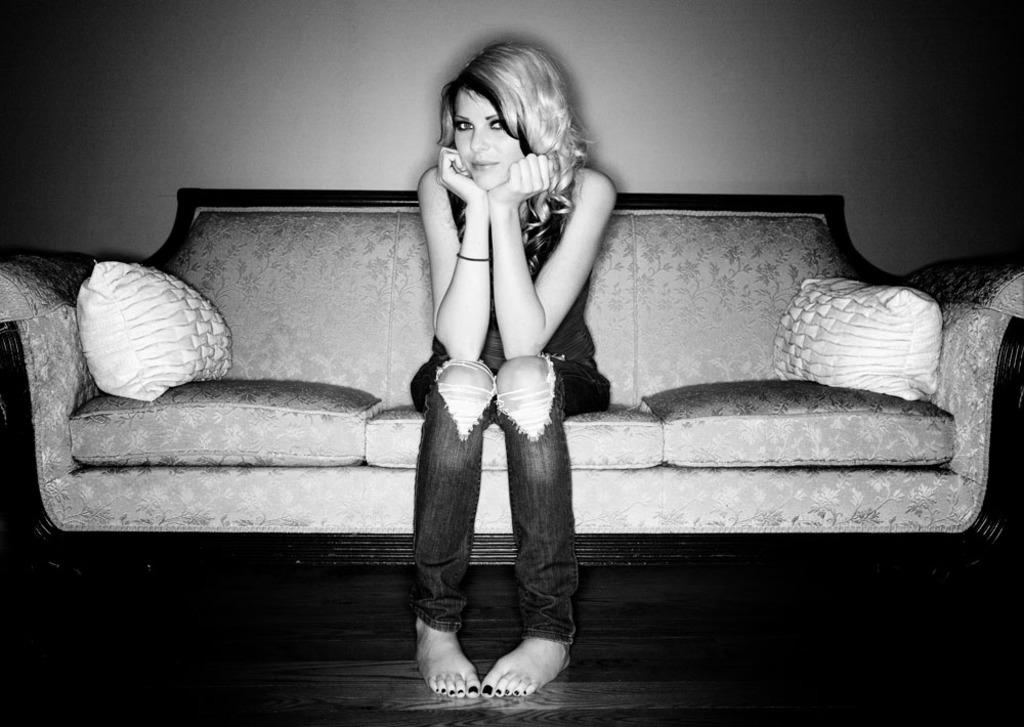What is the person in the image doing? There is a person sitting on the couch in the image. How many pillows are visible in the image? There are two pillows in the image. What is the background of the image? There is a wall in the image. What is the color scheme of the image? The image is in black and white. What type of copper basket can be seen on the wall in the image? There is no copper basket present in the image; the image is in black and white, and the wall is not described as having any baskets. 